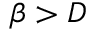Convert formula to latex. <formula><loc_0><loc_0><loc_500><loc_500>\beta > D</formula> 